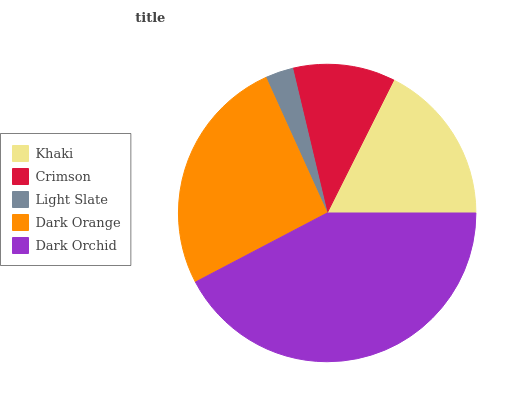Is Light Slate the minimum?
Answer yes or no. Yes. Is Dark Orchid the maximum?
Answer yes or no. Yes. Is Crimson the minimum?
Answer yes or no. No. Is Crimson the maximum?
Answer yes or no. No. Is Khaki greater than Crimson?
Answer yes or no. Yes. Is Crimson less than Khaki?
Answer yes or no. Yes. Is Crimson greater than Khaki?
Answer yes or no. No. Is Khaki less than Crimson?
Answer yes or no. No. Is Khaki the high median?
Answer yes or no. Yes. Is Khaki the low median?
Answer yes or no. Yes. Is Dark Orange the high median?
Answer yes or no. No. Is Dark Orange the low median?
Answer yes or no. No. 